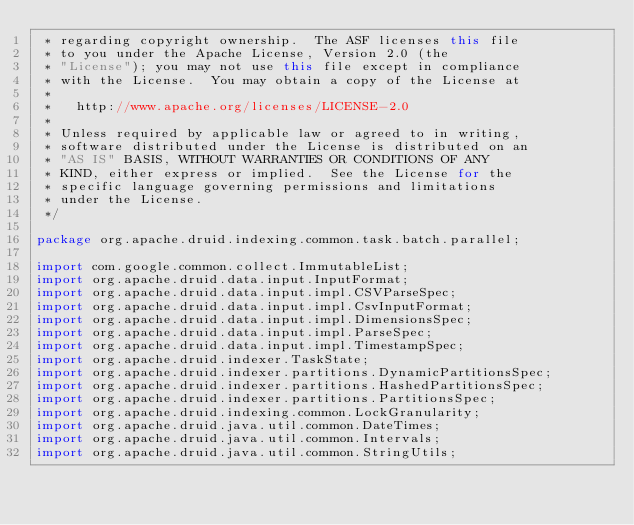Convert code to text. <code><loc_0><loc_0><loc_500><loc_500><_Java_> * regarding copyright ownership.  The ASF licenses this file
 * to you under the Apache License, Version 2.0 (the
 * "License"); you may not use this file except in compliance
 * with the License.  You may obtain a copy of the License at
 *
 *   http://www.apache.org/licenses/LICENSE-2.0
 *
 * Unless required by applicable law or agreed to in writing,
 * software distributed under the License is distributed on an
 * "AS IS" BASIS, WITHOUT WARRANTIES OR CONDITIONS OF ANY
 * KIND, either express or implied.  See the License for the
 * specific language governing permissions and limitations
 * under the License.
 */

package org.apache.druid.indexing.common.task.batch.parallel;

import com.google.common.collect.ImmutableList;
import org.apache.druid.data.input.InputFormat;
import org.apache.druid.data.input.impl.CSVParseSpec;
import org.apache.druid.data.input.impl.CsvInputFormat;
import org.apache.druid.data.input.impl.DimensionsSpec;
import org.apache.druid.data.input.impl.ParseSpec;
import org.apache.druid.data.input.impl.TimestampSpec;
import org.apache.druid.indexer.TaskState;
import org.apache.druid.indexer.partitions.DynamicPartitionsSpec;
import org.apache.druid.indexer.partitions.HashedPartitionsSpec;
import org.apache.druid.indexer.partitions.PartitionsSpec;
import org.apache.druid.indexing.common.LockGranularity;
import org.apache.druid.java.util.common.DateTimes;
import org.apache.druid.java.util.common.Intervals;
import org.apache.druid.java.util.common.StringUtils;</code> 